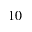Convert formula to latex. <formula><loc_0><loc_0><loc_500><loc_500>1 0</formula> 